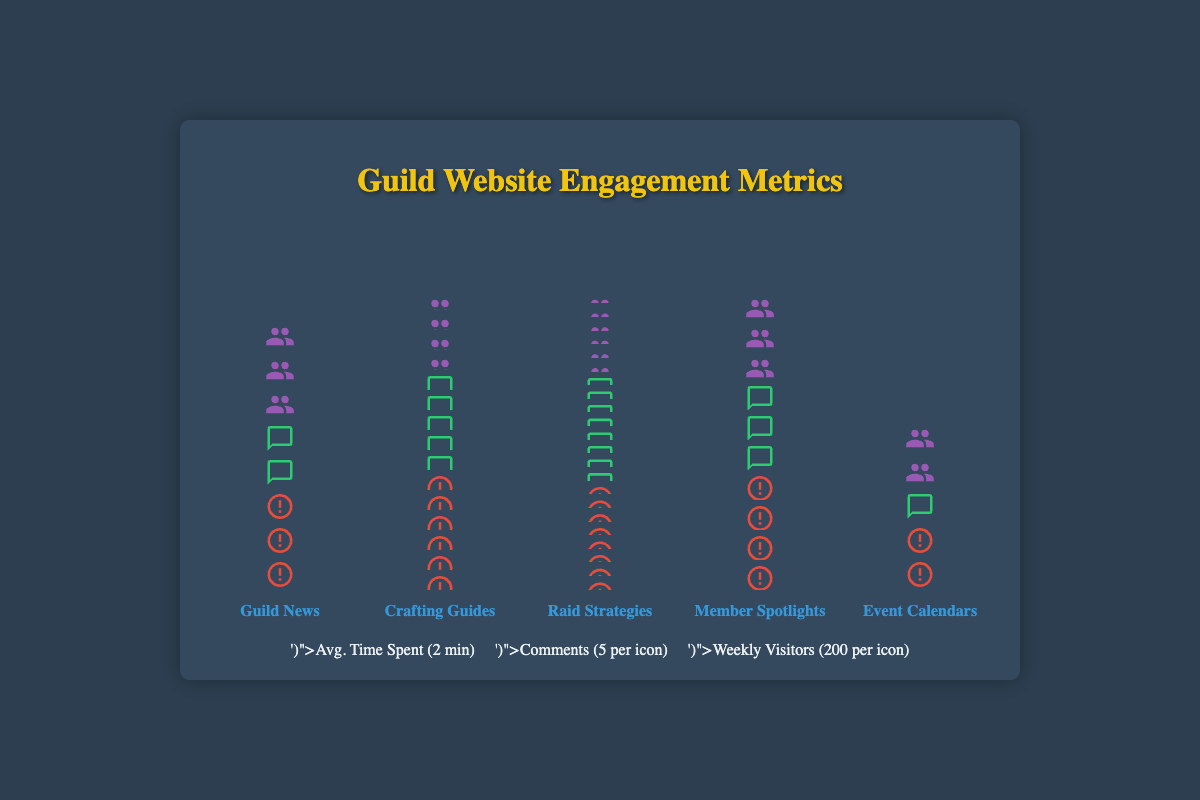What's the title of the figure? The title is usually written at the top of the plot and helps to understand the overall topic. Here, the title is "Guild Website Engagement Metrics".
Answer: Guild Website Engagement Metrics Which content category has the highest number of weekly unique visitors? By visually comparing the height and the number of icons representing weekly unique visitors for each category, 'Raid Strategies' has the most, represented by 6 icons (each representing 200 visitors).
Answer: Raid Strategies How much average time is spent on 'Crafting Guides'? Look at the red icons representing average time spent for the 'Crafting Guides' category. Count these icons and then multiply by 2 minutes per icon (as per the legend). There are 6 icons, so 6 * 2 = 12 minutes.
Answer: 12 minutes What is the difference in weekly unique visitors between 'Raid Strategies' and 'Event Calendars'? Count the purple icons for both categories and calculate the difference. 'Raid Strategies' has 6 icons and 'Event Calendars' has 2 icons. So, (6 * 200) - (2 * 200) = 1200 - 400 = 800 visitors.
Answer: 800 visitors Which two categories have the fewest comments per post, and how many comments are there for each? Look at the green icons representing comments per post. 'Guild News' and 'Event Calendars' both have 2 green icons each. Each icon represents 5 comments per the legend, so both categories have 2 * 5 = 10 comments per post.
Answer: Guild News and Event Calendars, 10 comments each Compare the average time spent on 'Raid Strategies' and 'Member Spotlights'. Which one has more and by how much? Count the red icons for both categories. 'Raid Strategies' has 8 icons, and 'Member Spotlights' has 4 icons. Each icon represents 2 minutes, so the time difference is (8 - 4) * 2 = 4 * 2 = 8 minutes.
Answer: Raid Strategies, 8 minutes What is the ratio of average time spent on 'Guild News' to the average time spent on 'Event Calendars'? Count red icons for both categories. 'Guild News' has 3 icons and 'Event Calendars' has 1. Each icon represents 2 minutes. So, the ratio is (3 * 2) / (1 * 2) = 6 / 2 = 3:1.
Answer: 3:1 What is the sum of weekly unique visitors for 'Crafting Guides' and 'Member Spotlights'? Count the purple icons for both categories. 'Crafting Guides' has 4 icons and 'Member Spotlights' has 3. Each icon represents 200 visitors. So, (4 * 200) + (3 * 200) = 800 + 600 = 1400 visitors.
Answer: 1400 visitors Which category has the second-highest number of comments per post, and how many comments? Count the green icons representing comments for each. 'Crafting Guides' is the highest with 5 icons. 'Member Spotlight' is the second-highest with 3 icons. Each icon represents 5 comments, so 3 * 5 = 15 comments per post.
Answer: Member Spotlights, 15 comments 